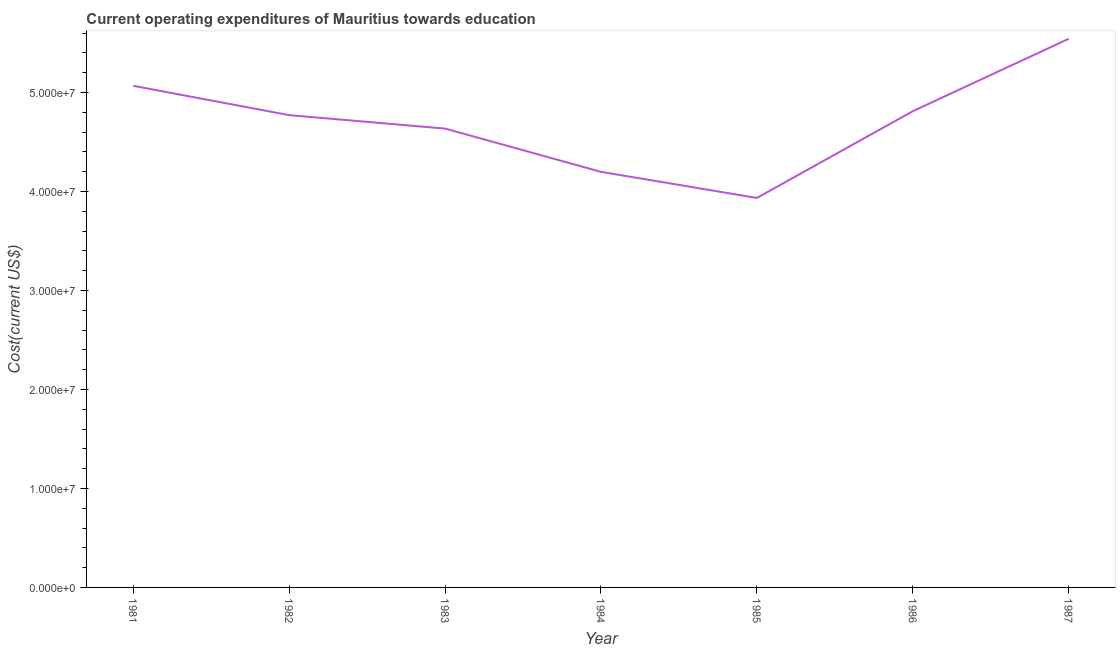What is the education expenditure in 1984?
Make the answer very short. 4.20e+07. Across all years, what is the maximum education expenditure?
Offer a terse response. 5.54e+07. Across all years, what is the minimum education expenditure?
Your answer should be very brief. 3.93e+07. In which year was the education expenditure maximum?
Ensure brevity in your answer.  1987. In which year was the education expenditure minimum?
Provide a short and direct response. 1985. What is the sum of the education expenditure?
Give a very brief answer. 3.30e+08. What is the difference between the education expenditure in 1981 and 1986?
Make the answer very short. 2.56e+06. What is the average education expenditure per year?
Make the answer very short. 4.71e+07. What is the median education expenditure?
Provide a short and direct response. 4.77e+07. In how many years, is the education expenditure greater than 34000000 US$?
Your answer should be compact. 7. What is the ratio of the education expenditure in 1981 to that in 1985?
Offer a terse response. 1.29. Is the difference between the education expenditure in 1983 and 1985 greater than the difference between any two years?
Offer a terse response. No. What is the difference between the highest and the second highest education expenditure?
Make the answer very short. 4.75e+06. Is the sum of the education expenditure in 1982 and 1983 greater than the maximum education expenditure across all years?
Provide a succinct answer. Yes. What is the difference between the highest and the lowest education expenditure?
Offer a terse response. 1.61e+07. How many lines are there?
Your answer should be compact. 1. How many years are there in the graph?
Offer a very short reply. 7. Are the values on the major ticks of Y-axis written in scientific E-notation?
Give a very brief answer. Yes. Does the graph contain grids?
Offer a terse response. No. What is the title of the graph?
Your answer should be very brief. Current operating expenditures of Mauritius towards education. What is the label or title of the X-axis?
Make the answer very short. Year. What is the label or title of the Y-axis?
Your answer should be very brief. Cost(current US$). What is the Cost(current US$) of 1981?
Give a very brief answer. 5.07e+07. What is the Cost(current US$) of 1982?
Offer a terse response. 4.77e+07. What is the Cost(current US$) in 1983?
Your answer should be very brief. 4.64e+07. What is the Cost(current US$) of 1984?
Provide a succinct answer. 4.20e+07. What is the Cost(current US$) in 1985?
Keep it short and to the point. 3.93e+07. What is the Cost(current US$) of 1986?
Keep it short and to the point. 4.81e+07. What is the Cost(current US$) of 1987?
Offer a very short reply. 5.54e+07. What is the difference between the Cost(current US$) in 1981 and 1982?
Provide a succinct answer. 2.96e+06. What is the difference between the Cost(current US$) in 1981 and 1983?
Make the answer very short. 4.32e+06. What is the difference between the Cost(current US$) in 1981 and 1984?
Provide a succinct answer. 8.69e+06. What is the difference between the Cost(current US$) in 1981 and 1985?
Provide a short and direct response. 1.13e+07. What is the difference between the Cost(current US$) in 1981 and 1986?
Your answer should be compact. 2.56e+06. What is the difference between the Cost(current US$) in 1981 and 1987?
Ensure brevity in your answer.  -4.75e+06. What is the difference between the Cost(current US$) in 1982 and 1983?
Provide a succinct answer. 1.36e+06. What is the difference between the Cost(current US$) in 1982 and 1984?
Ensure brevity in your answer.  5.73e+06. What is the difference between the Cost(current US$) in 1982 and 1985?
Ensure brevity in your answer.  8.37e+06. What is the difference between the Cost(current US$) in 1982 and 1986?
Offer a terse response. -3.99e+05. What is the difference between the Cost(current US$) in 1982 and 1987?
Keep it short and to the point. -7.71e+06. What is the difference between the Cost(current US$) in 1983 and 1984?
Ensure brevity in your answer.  4.37e+06. What is the difference between the Cost(current US$) in 1983 and 1985?
Your response must be concise. 7.01e+06. What is the difference between the Cost(current US$) in 1983 and 1986?
Your answer should be compact. -1.76e+06. What is the difference between the Cost(current US$) in 1983 and 1987?
Give a very brief answer. -9.07e+06. What is the difference between the Cost(current US$) in 1984 and 1985?
Keep it short and to the point. 2.64e+06. What is the difference between the Cost(current US$) in 1984 and 1986?
Offer a terse response. -6.13e+06. What is the difference between the Cost(current US$) in 1984 and 1987?
Provide a succinct answer. -1.34e+07. What is the difference between the Cost(current US$) in 1985 and 1986?
Your answer should be compact. -8.77e+06. What is the difference between the Cost(current US$) in 1985 and 1987?
Ensure brevity in your answer.  -1.61e+07. What is the difference between the Cost(current US$) in 1986 and 1987?
Provide a succinct answer. -7.31e+06. What is the ratio of the Cost(current US$) in 1981 to that in 1982?
Make the answer very short. 1.06. What is the ratio of the Cost(current US$) in 1981 to that in 1983?
Provide a short and direct response. 1.09. What is the ratio of the Cost(current US$) in 1981 to that in 1984?
Keep it short and to the point. 1.21. What is the ratio of the Cost(current US$) in 1981 to that in 1985?
Keep it short and to the point. 1.29. What is the ratio of the Cost(current US$) in 1981 to that in 1986?
Keep it short and to the point. 1.05. What is the ratio of the Cost(current US$) in 1981 to that in 1987?
Your answer should be compact. 0.91. What is the ratio of the Cost(current US$) in 1982 to that in 1984?
Offer a very short reply. 1.14. What is the ratio of the Cost(current US$) in 1982 to that in 1985?
Your answer should be very brief. 1.21. What is the ratio of the Cost(current US$) in 1982 to that in 1986?
Offer a terse response. 0.99. What is the ratio of the Cost(current US$) in 1982 to that in 1987?
Your answer should be very brief. 0.86. What is the ratio of the Cost(current US$) in 1983 to that in 1984?
Ensure brevity in your answer.  1.1. What is the ratio of the Cost(current US$) in 1983 to that in 1985?
Give a very brief answer. 1.18. What is the ratio of the Cost(current US$) in 1983 to that in 1986?
Make the answer very short. 0.96. What is the ratio of the Cost(current US$) in 1983 to that in 1987?
Your answer should be very brief. 0.84. What is the ratio of the Cost(current US$) in 1984 to that in 1985?
Your response must be concise. 1.07. What is the ratio of the Cost(current US$) in 1984 to that in 1986?
Your answer should be very brief. 0.87. What is the ratio of the Cost(current US$) in 1984 to that in 1987?
Make the answer very short. 0.76. What is the ratio of the Cost(current US$) in 1985 to that in 1986?
Offer a terse response. 0.82. What is the ratio of the Cost(current US$) in 1985 to that in 1987?
Provide a short and direct response. 0.71. What is the ratio of the Cost(current US$) in 1986 to that in 1987?
Make the answer very short. 0.87. 